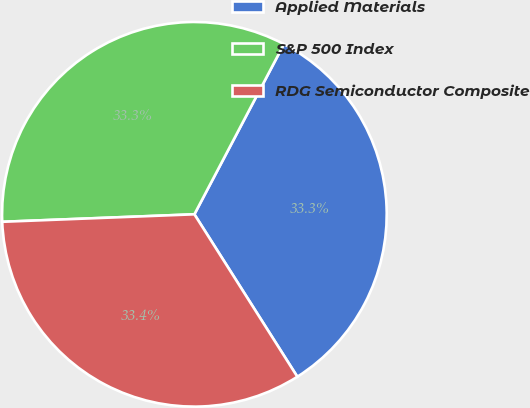Convert chart. <chart><loc_0><loc_0><loc_500><loc_500><pie_chart><fcel>Applied Materials<fcel>S&P 500 Index<fcel>RDG Semiconductor Composite<nl><fcel>33.3%<fcel>33.33%<fcel>33.37%<nl></chart> 